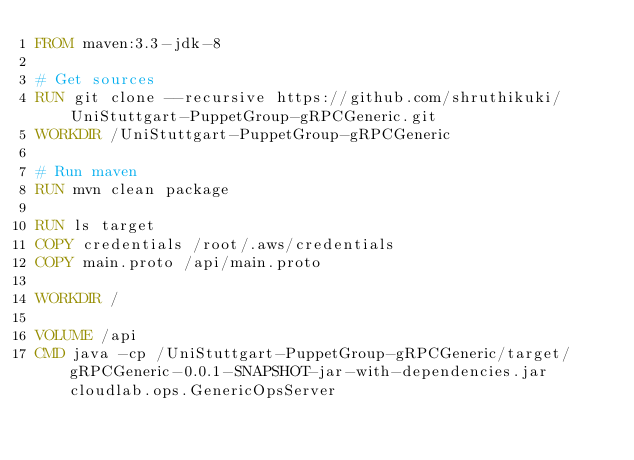<code> <loc_0><loc_0><loc_500><loc_500><_Dockerfile_>FROM maven:3.3-jdk-8

# Get sources
RUN git clone --recursive https://github.com/shruthikuki/UniStuttgart-PuppetGroup-gRPCGeneric.git
WORKDIR /UniStuttgart-PuppetGroup-gRPCGeneric

# Run maven
RUN mvn clean package

RUN ls target
COPY credentials /root/.aws/credentials
COPY main.proto /api/main.proto

WORKDIR /

VOLUME /api
CMD java -cp /UniStuttgart-PuppetGroup-gRPCGeneric/target/gRPCGeneric-0.0.1-SNAPSHOT-jar-with-dependencies.jar cloudlab.ops.GenericOpsServer
</code> 